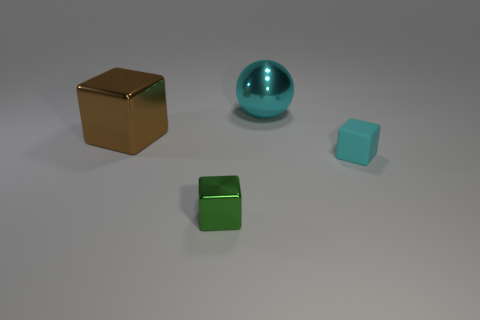Add 4 large green metallic spheres. How many objects exist? 8 Subtract all spheres. How many objects are left? 3 Subtract all large green rubber cylinders. Subtract all tiny green cubes. How many objects are left? 3 Add 1 metallic blocks. How many metallic blocks are left? 3 Add 3 large brown metallic cubes. How many large brown metallic cubes exist? 4 Subtract 0 gray balls. How many objects are left? 4 